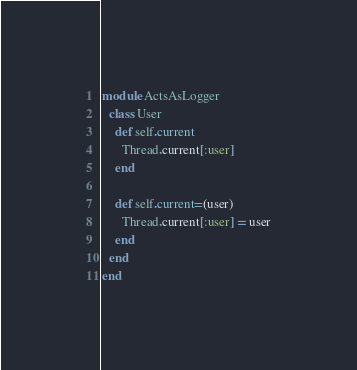<code> <loc_0><loc_0><loc_500><loc_500><_Ruby_>module ActsAsLogger
  class User
    def self.current
      Thread.current[:user]
    end

    def self.current=(user)
      Thread.current[:user] = user
    end
  end
end</code> 